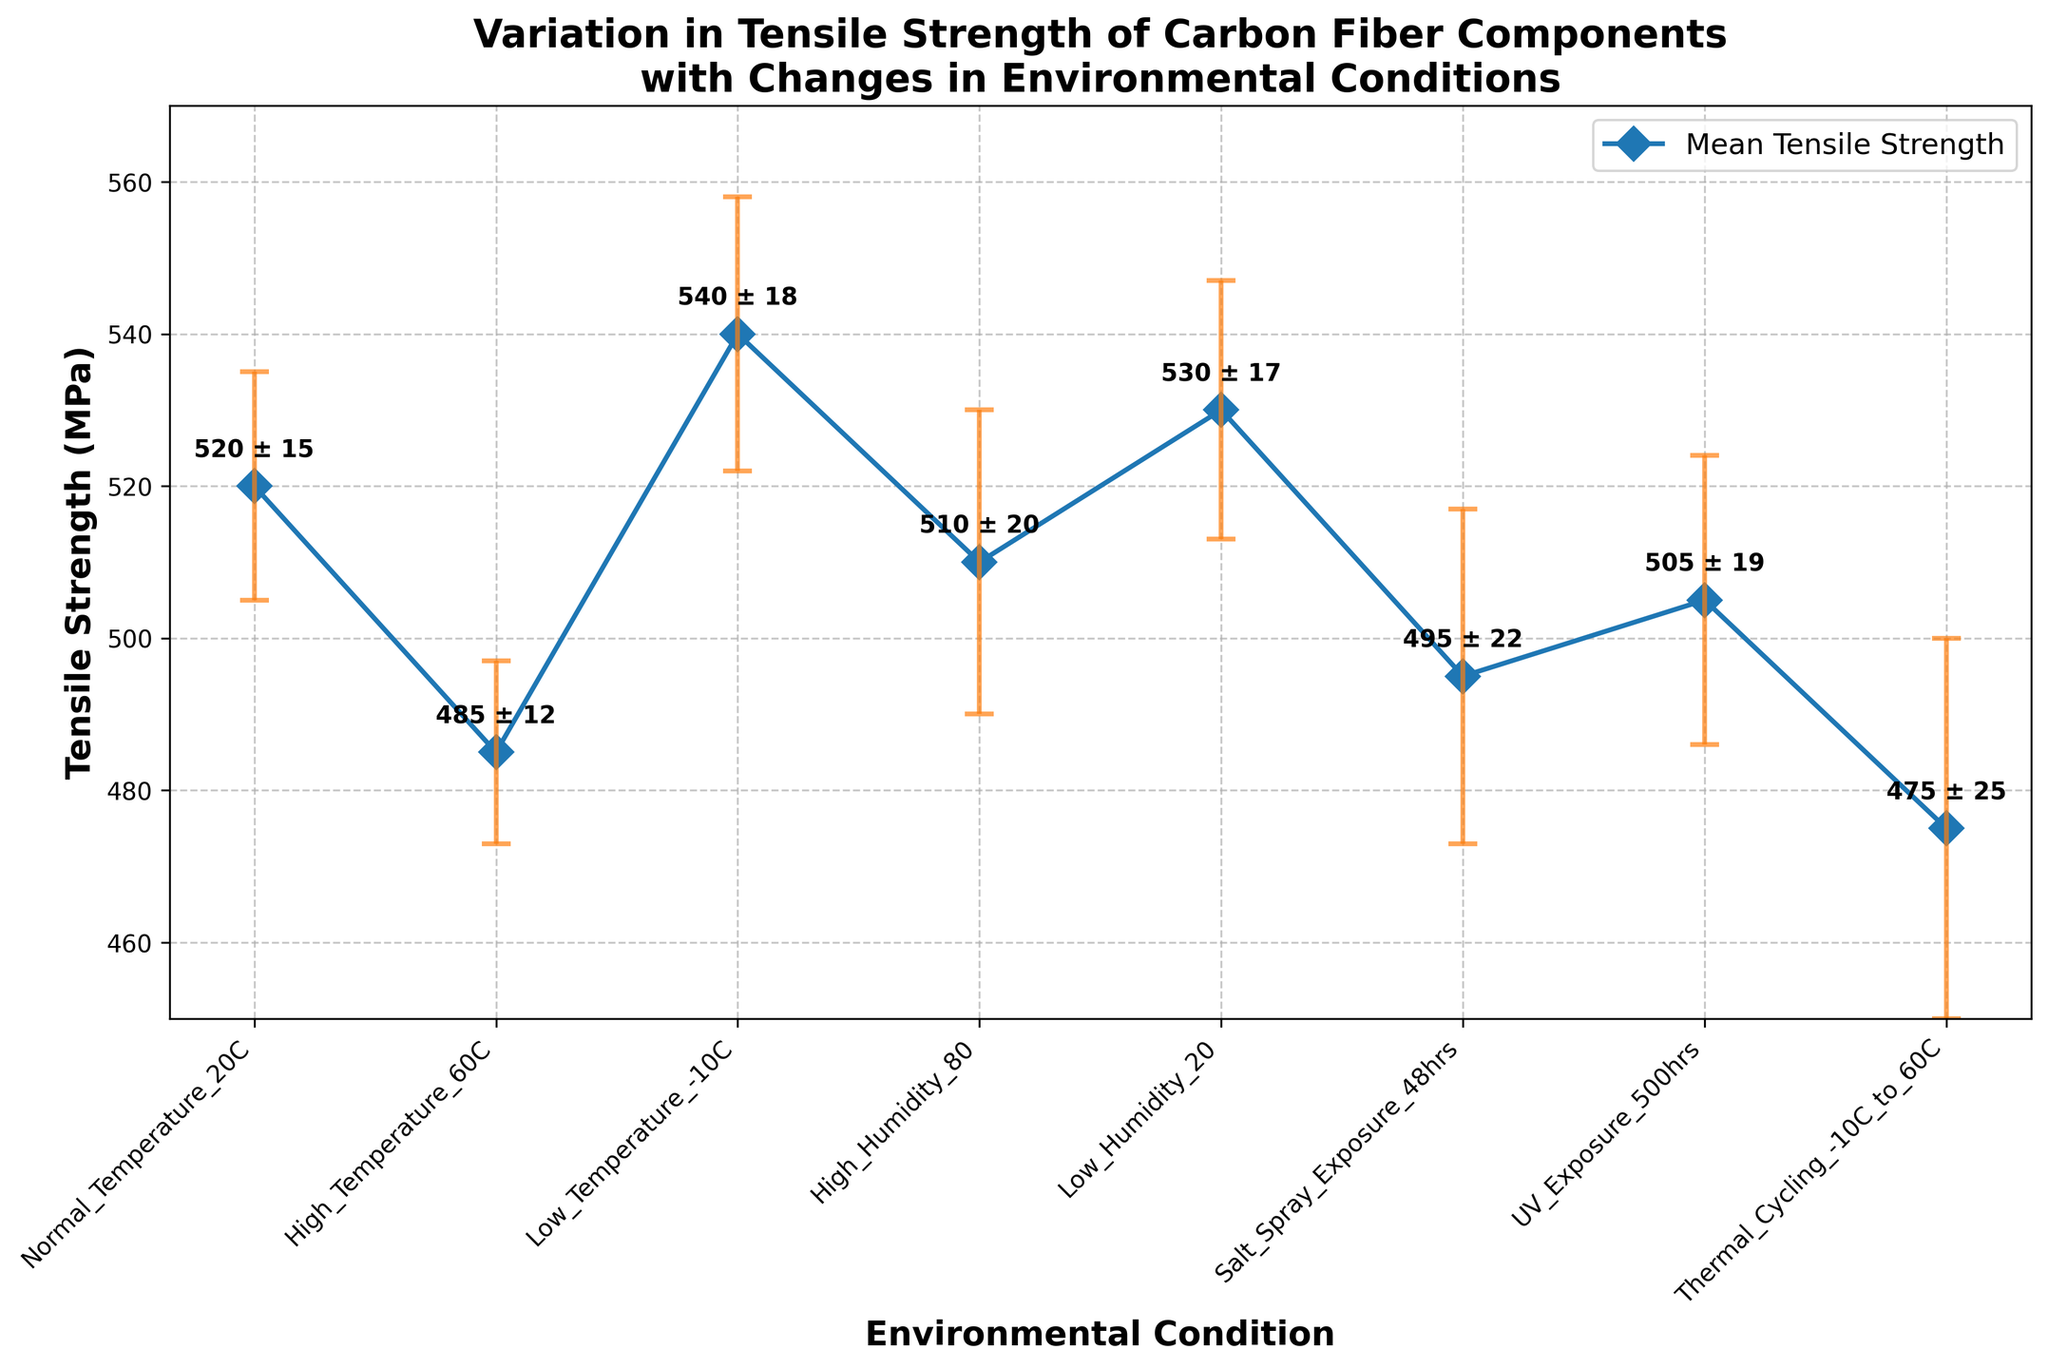How many environmental conditions are analyzed in the figure? Count the number of distinct environmental conditions on the x-axis. The x-axis lists the environmental conditions, and there are 8 distinct labels.
Answer: 8 What is the title of the figure? Look at the top of the figure where the title is typically placed. The title is clearly written for the figure.
Answer: Variation in Tensile Strength of Carbon Fiber Components with Changes in Environmental Conditions Which environmental condition has the highest mean tensile strength? Identify the highest point on the y-axis (Mean Tensile Strength) and trace it back to the corresponding x-axis label. The point at the highest y-value is for Low Temperature (-10C).
Answer: Low Temperature (-10C) What is the mean tensile strength under High Humidity (80)? Locate the point on the plot corresponding to High Humidity (80) on the x-axis and refer to its y-value. The plot shows a y-value of 510 MPa for High Humidity (80).
Answer: 510 MPa Which environmental condition has the largest standard deviation in tensile strength? Identify the error bar with the largest vertical span, indicating the standard deviation. The largest error bar corresponds to Thermal Cycling (-10C to 60C).
Answer: Thermal Cycling (-10C to 60C) What is the difference in mean tensile strength between Normal Temperature (20C) and High Temperature (60C)? Subtract the mean tensile strength of High Temperature (60C) from that of Normal Temperature (20C), i.e., 520 MPa - 485 MPa.
Answer: 35 MPa How does the tensile strength under UV Exposure (500 hrs) compare to that under Salt Spray Exposure (48 hrs)? Compare the y-values of the points corresponding to UV Exposure (500 hrs) and Salt Spray Exposure (48 hrs). UV Exposure (500 hrs) has a tensile strength of 505 MPa, which is higher than Salt Spray Exposure (48 hrs) with 495 MPa.
Answer: Higher Which environmental condition has the lowest mean tensile strength, and what is that value? Identify the lowest point on the plot and trace it back to the corresponding x-axis label. The lowest point corresponds to Thermal Cycling (-10C to 60C) at 475 MPa.
Answer: Thermal Cycling (-10C to 60C), 475 MPa What is the average mean tensile strength across all conditions? Sum the mean tensile strengths of all conditions and divide by the number of conditions (520 + 485 + 540 + 510 + 530 + 495 + 505 + 475) / 8.
Answer: 507.5 MPa Which two environmental conditions have a mean tensile strength difference closest to zero? Calculate the absolute differences between each pair of mean tensile strengths and identify the pair with the smallest difference. The smallest difference is between Salt Spray Exposure (48 hrs) with 495 MPa and UV Exposure (500 hrs) with 505 MPa, having a difference of 10 MPa.
Answer: Salt Spray Exposure (48 hrs) and UV Exposure (500 hrs) 